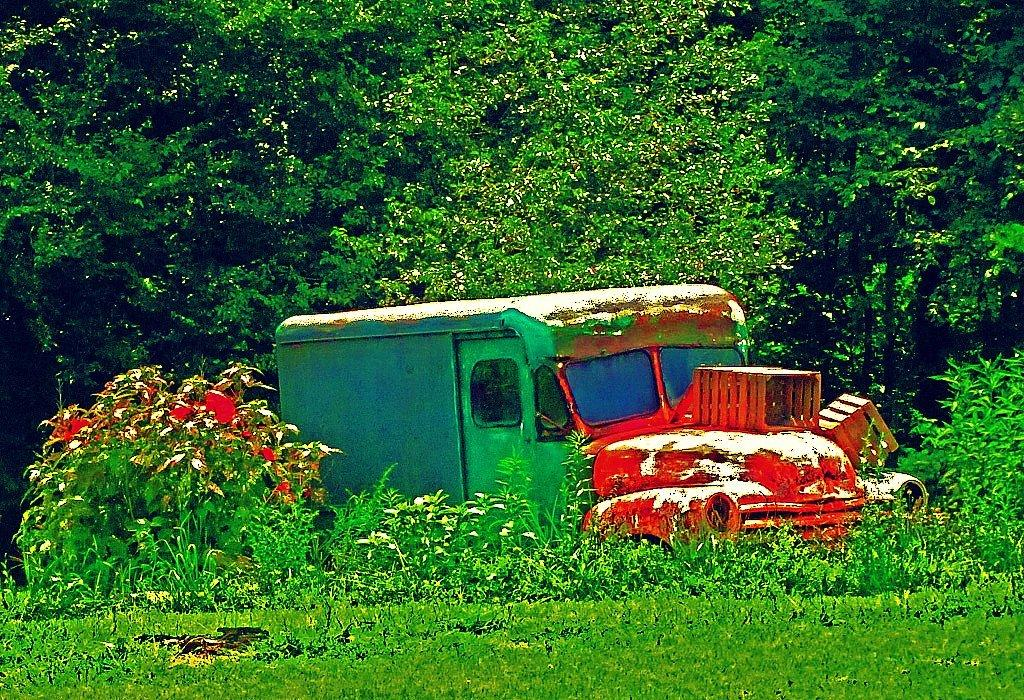What is the main subject of the image? The main subject of the image is a truck. What can be seen on the truck? There are objects on the truck. What type of vegetation is in front of the truck? There are plants and grass in front of the truck. What is visible behind the truck? There are trees behind the truck. How many oranges are being pulled by the truck in the image? There are no oranges or any indication of pulling in the image; it features a truck with objects on it and a surrounding landscape of plants, grass, and trees. 